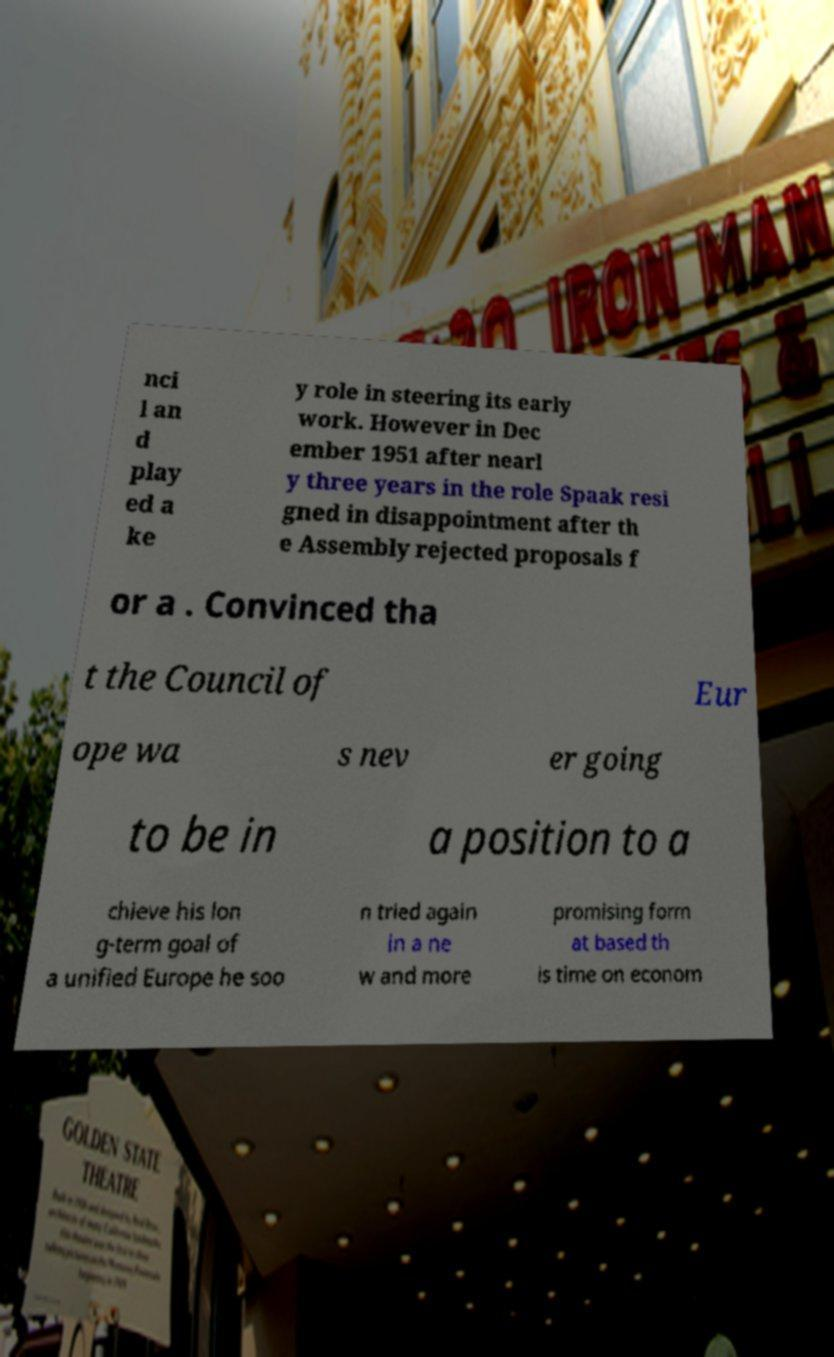Could you extract and type out the text from this image? nci l an d play ed a ke y role in steering its early work. However in Dec ember 1951 after nearl y three years in the role Spaak resi gned in disappointment after th e Assembly rejected proposals f or a . Convinced tha t the Council of Eur ope wa s nev er going to be in a position to a chieve his lon g-term goal of a unified Europe he soo n tried again in a ne w and more promising form at based th is time on econom 